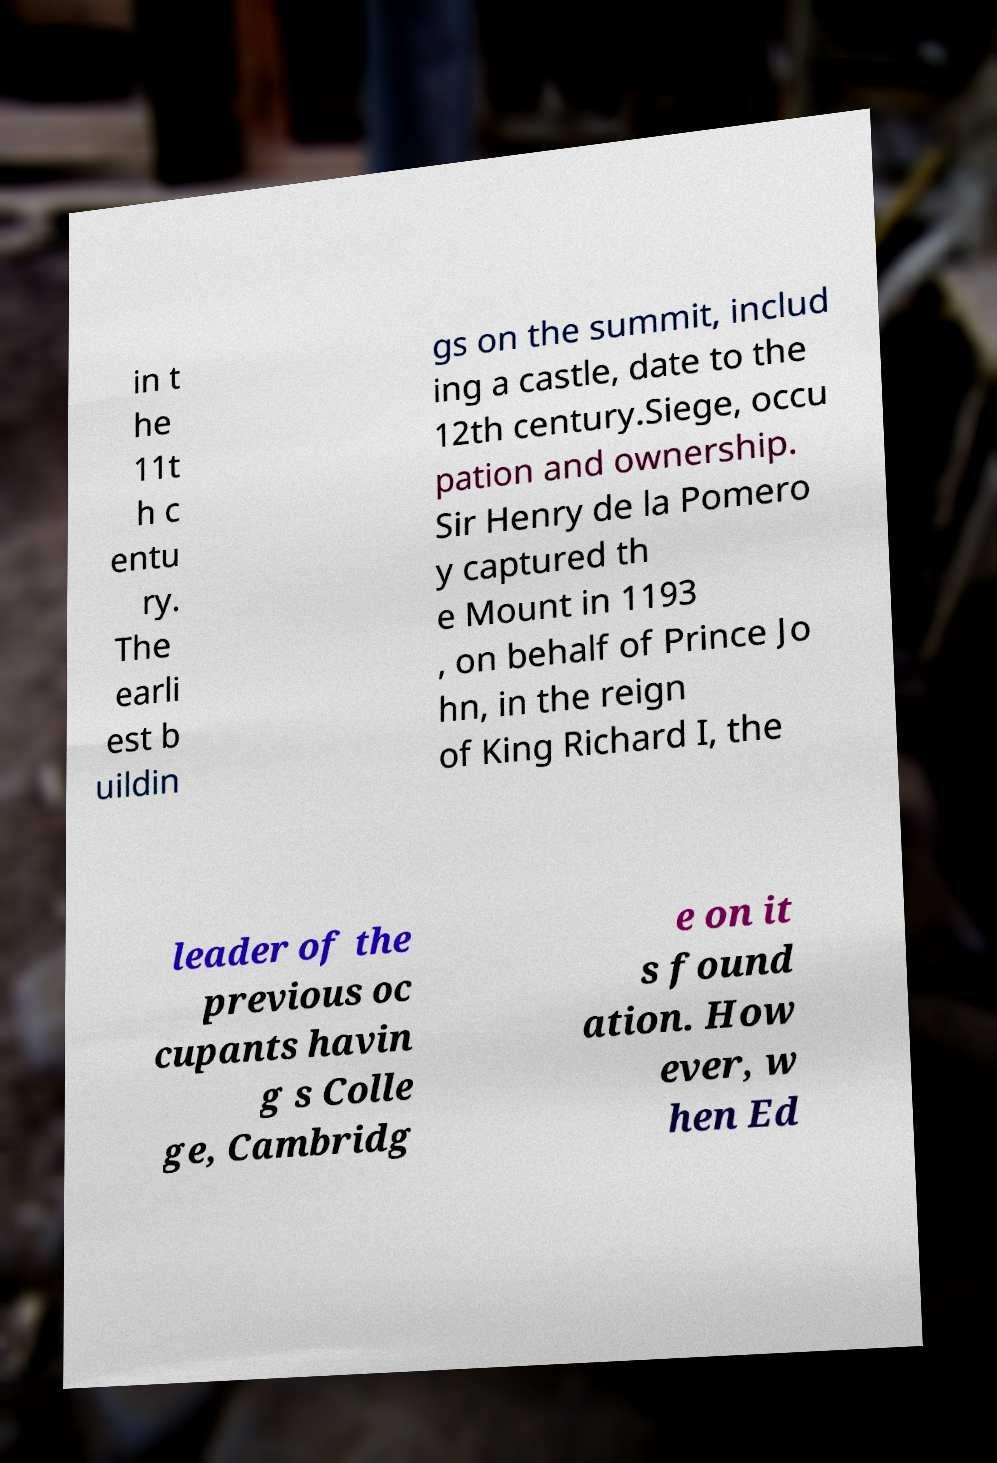Please identify and transcribe the text found in this image. in t he 11t h c entu ry. The earli est b uildin gs on the summit, includ ing a castle, date to the 12th century.Siege, occu pation and ownership. Sir Henry de la Pomero y captured th e Mount in 1193 , on behalf of Prince Jo hn, in the reign of King Richard I, the leader of the previous oc cupants havin g s Colle ge, Cambridg e on it s found ation. How ever, w hen Ed 